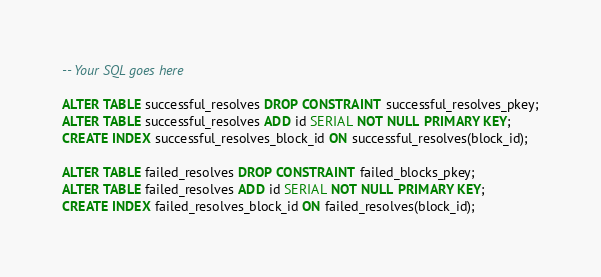<code> <loc_0><loc_0><loc_500><loc_500><_SQL_>-- Your SQL goes here

ALTER TABLE successful_resolves DROP CONSTRAINT successful_resolves_pkey;
ALTER TABLE successful_resolves ADD id SERIAL NOT NULL PRIMARY KEY;
CREATE INDEX successful_resolves_block_id ON successful_resolves(block_id);

ALTER TABLE failed_resolves DROP CONSTRAINT failed_blocks_pkey;
ALTER TABLE failed_resolves ADD id SERIAL NOT NULL PRIMARY KEY;
CREATE INDEX failed_resolves_block_id ON failed_resolves(block_id);
</code> 